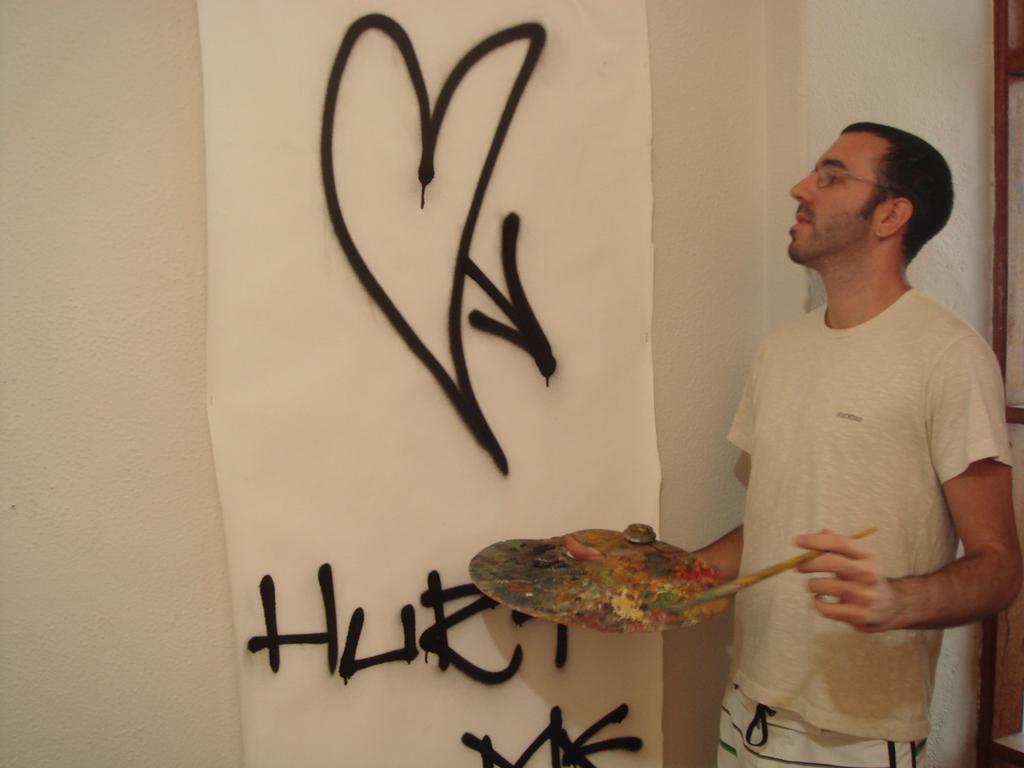Please provide a concise description of this image. In this image in the front there is a man standing and holding an object in his hand. In the center there is a banner and on the banner there is some text written on it. 